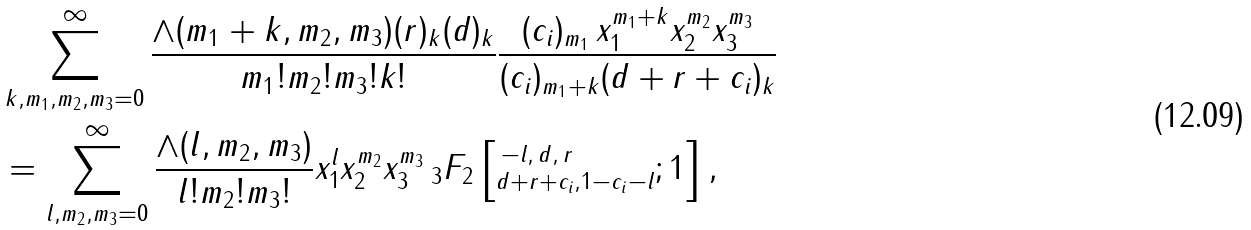Convert formula to latex. <formula><loc_0><loc_0><loc_500><loc_500>& \sum _ { k , m _ { 1 } , m _ { 2 } , m _ { 3 } = 0 } ^ { \infty } \frac { \wedge ( m _ { 1 } + k , m _ { 2 } , m _ { 3 } ) ( r ) _ { k } ( d ) _ { k } } { m _ { 1 } ! m _ { 2 } ! m _ { 3 } ! k ! } \frac { ( c _ { i } ) _ { m _ { 1 } } \, x _ { 1 } ^ { m _ { 1 } + k } x _ { 2 } ^ { m _ { 2 } } x _ { 3 } ^ { m _ { 3 } } } { ( c _ { i } ) _ { m _ { 1 } + k } ( d + r + c _ { i } ) _ { k } } \\ & = \sum _ { l , m _ { 2 } , m _ { 3 } = 0 } ^ { \infty } \frac { \wedge ( l , m _ { 2 } , m _ { 3 } ) } { l ! m _ { 2 } ! m _ { 3 } ! } x _ { 1 } ^ { l } x _ { 2 } ^ { m _ { 2 } } x _ { 3 } ^ { m _ { 3 } } \, _ { 3 } F _ { 2 } \left [ ^ { \, - l , \, d , \, r \, } _ { d + r + c _ { i } , 1 - c _ { i } - l } ; 1 \right ] ,</formula> 